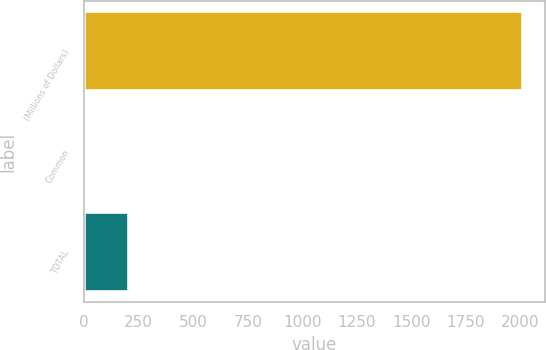Convert chart to OTSL. <chart><loc_0><loc_0><loc_500><loc_500><bar_chart><fcel>(Millions of Dollars)<fcel>Common<fcel>TOTAL<nl><fcel>2012<fcel>3<fcel>203.9<nl></chart> 